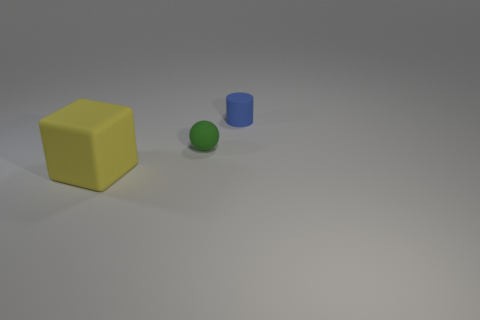Add 1 small rubber cylinders. How many objects exist? 4 Add 2 big things. How many big things exist? 3 Subtract 0 blue balls. How many objects are left? 3 Subtract all large things. Subtract all tiny blue matte objects. How many objects are left? 1 Add 2 blocks. How many blocks are left? 3 